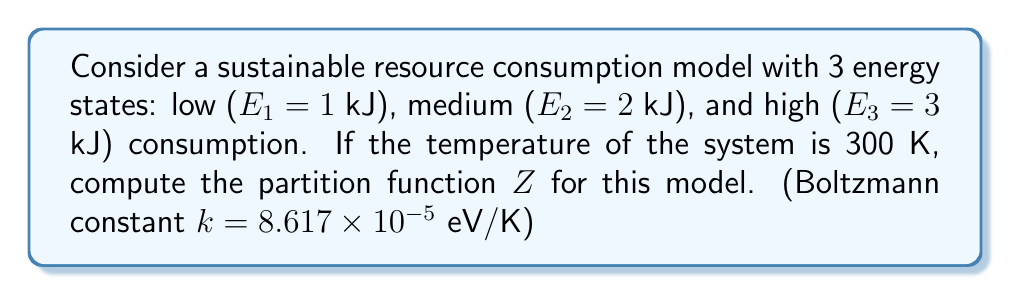Can you answer this question? To compute the partition function Z, we follow these steps:

1) The partition function is given by:
   $$Z = \sum_{i} e^{-\beta E_i}$$
   where $\beta = \frac{1}{k_B T}$, $k_B$ is the Boltzmann constant, and T is temperature.

2) Convert temperature and energies to consistent units:
   T = 300 K
   $k_B$ = 8.617 × 10⁻⁵ eV/K
   E₁ = 1 kJ = 6.242 × 10¹⁵ eV
   E₂ = 2 kJ = 1.248 × 10¹⁶ eV
   E₃ = 3 kJ = 1.873 × 10¹⁶ eV

3) Calculate $\beta$:
   $$\beta = \frac{1}{(8.617 \times 10^{-5} \text{ eV/K})(300 \text{ K})} = 38.68 \text{ eV}^{-1}$$

4) Calculate each term in the sum:
   $$e^{-\beta E_1} = e^{-(38.68)(6.242 \times 10^{15})} \approx 0$$
   $$e^{-\beta E_2} = e^{-(38.68)(1.248 \times 10^{16})} \approx 0$$
   $$e^{-\beta E_3} = e^{-(38.68)(1.873 \times 10^{16})} \approx 0$$

5) Sum the terms:
   $$Z = e^{-\beta E_1} + e^{-\beta E_2} + e^{-\beta E_3} \approx 0 + 0 + 0 = 0$$

Note: The result is approximately zero due to the extremely large negative exponents.
Answer: $Z \approx 0$ 